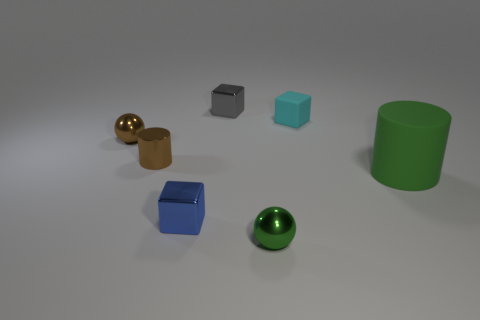There is a metallic sphere that is the same color as the big matte object; what is its size?
Ensure brevity in your answer.  Small. There is a metal thing that is the same color as the big rubber object; what is its shape?
Your answer should be very brief. Sphere. How many objects are either small brown things or tiny balls that are to the right of the brown sphere?
Provide a succinct answer. 3. The green thing that is the same size as the blue cube is what shape?
Give a very brief answer. Sphere. How many small balls are the same color as the metal cylinder?
Offer a very short reply. 1. Are the ball to the right of the brown cylinder and the gray block made of the same material?
Your response must be concise. Yes. What is the shape of the blue thing?
Give a very brief answer. Cube. How many red things are large rubber cylinders or shiny cubes?
Your response must be concise. 0. How many other things are there of the same material as the tiny green sphere?
Provide a succinct answer. 4. There is a green thing on the right side of the small green thing; is its shape the same as the green metal object?
Your response must be concise. No. 